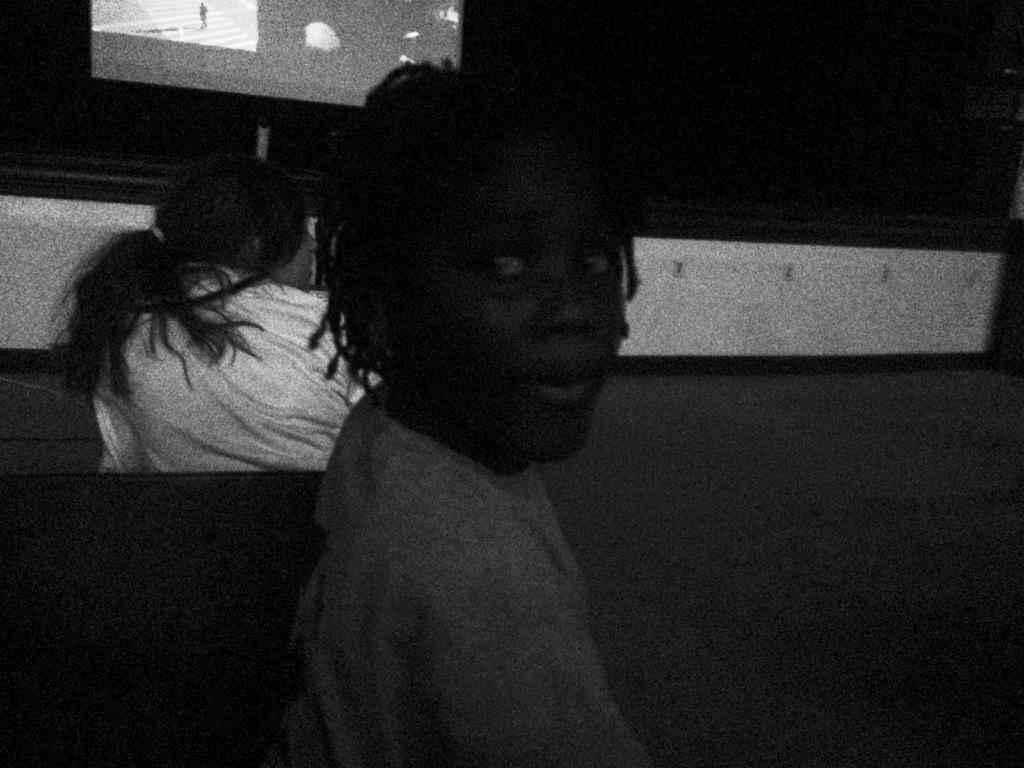Who or what can be seen in the image? There are people in the image. What electronic device is present in the image? There is a television in the image. How would you describe the lighting in the image? The background of the image is dark. What type of veil can be seen on the people in the image? There is no veil present on the people in the image. 